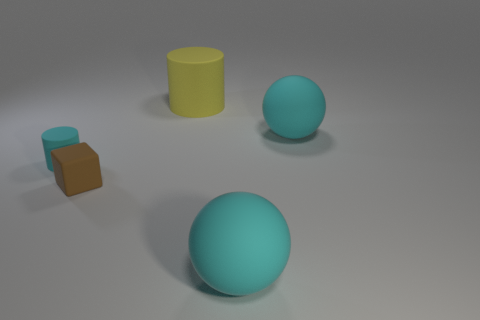There is another object that is the same shape as the yellow matte object; what size is it?
Provide a short and direct response. Small. What number of yellow objects have the same size as the rubber cube?
Give a very brief answer. 0. What is the tiny brown cube made of?
Your answer should be compact. Rubber. Are there any brown rubber cubes to the left of the big yellow matte cylinder?
Provide a succinct answer. Yes. There is another cylinder that is made of the same material as the large yellow cylinder; what size is it?
Give a very brief answer. Small. How many objects are the same color as the small rubber cylinder?
Your response must be concise. 2. Is the number of small objects in front of the small brown matte cube less than the number of cyan matte things that are on the right side of the big cylinder?
Give a very brief answer. Yes. How big is the cyan matte sphere that is in front of the brown object?
Keep it short and to the point. Large. Is there another tiny green block that has the same material as the block?
Offer a very short reply. No. Do the small brown block and the small cylinder have the same material?
Keep it short and to the point. Yes. 